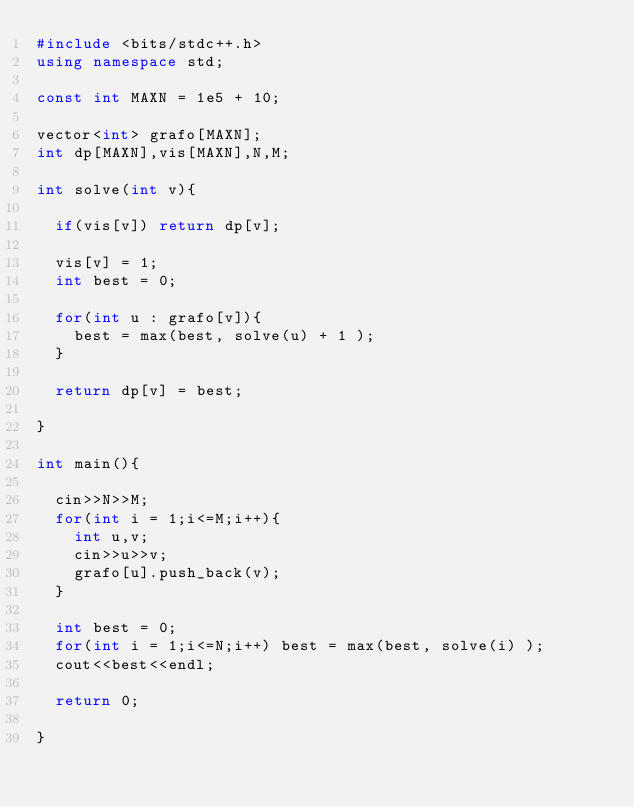Convert code to text. <code><loc_0><loc_0><loc_500><loc_500><_C++_>#include <bits/stdc++.h>
using namespace std;

const int MAXN = 1e5 + 10;

vector<int> grafo[MAXN];
int dp[MAXN],vis[MAXN],N,M;

int solve(int v){

	if(vis[v]) return dp[v];

	vis[v] = 1;
	int best = 0;

	for(int u : grafo[v]){
		best = max(best, solve(u) + 1 );
	}

	return dp[v] = best;

}

int main(){

	cin>>N>>M;
	for(int i = 1;i<=M;i++){
		int u,v;
		cin>>u>>v;
		grafo[u].push_back(v);
	}

	int best = 0;
	for(int i = 1;i<=N;i++) best = max(best, solve(i) );
	cout<<best<<endl;

	return 0;

}</code> 